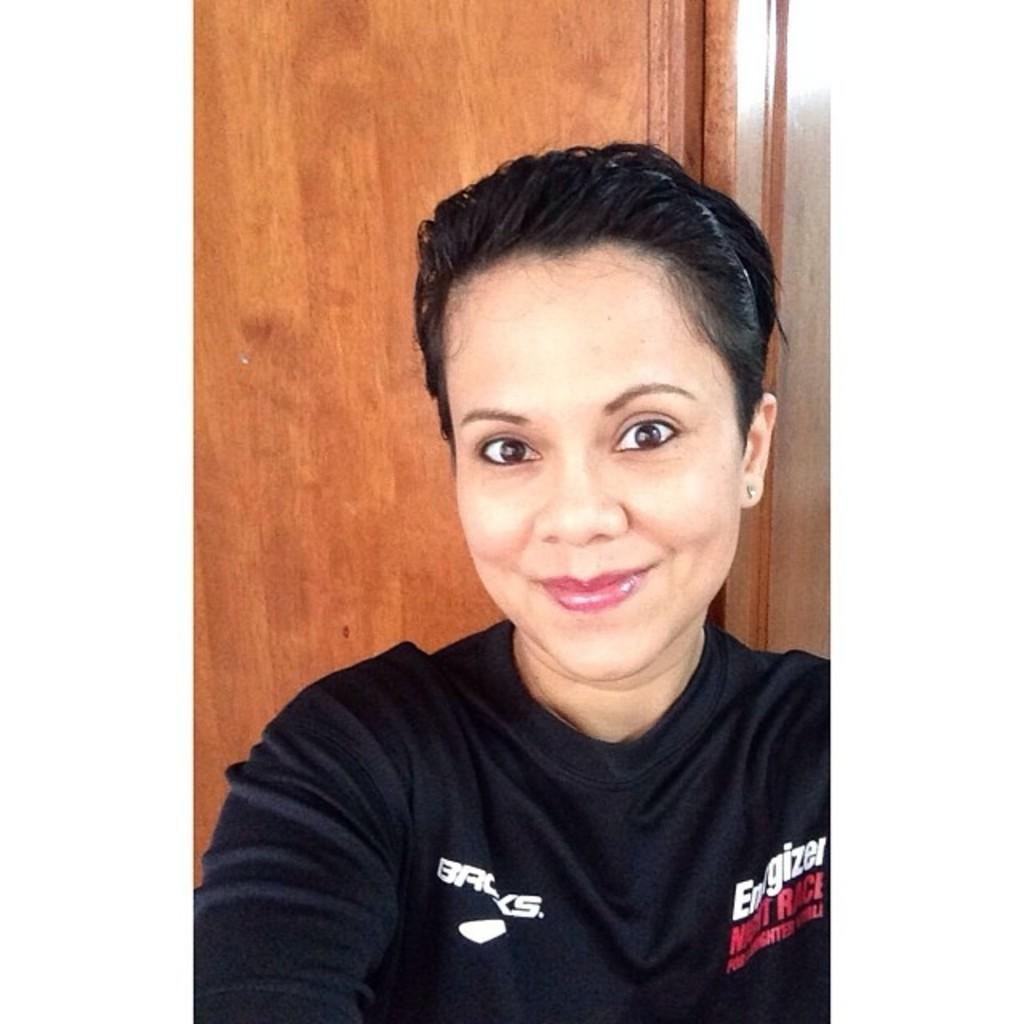<image>
Render a clear and concise summary of the photo. A woman is wearing a shirt that says, 'Energizer Night Race'. 